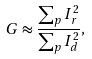<formula> <loc_0><loc_0><loc_500><loc_500>G \approx \frac { \sum _ { p } I _ { r } ^ { 2 } } { \sum _ { p } I _ { d } ^ { 2 } } ,</formula> 